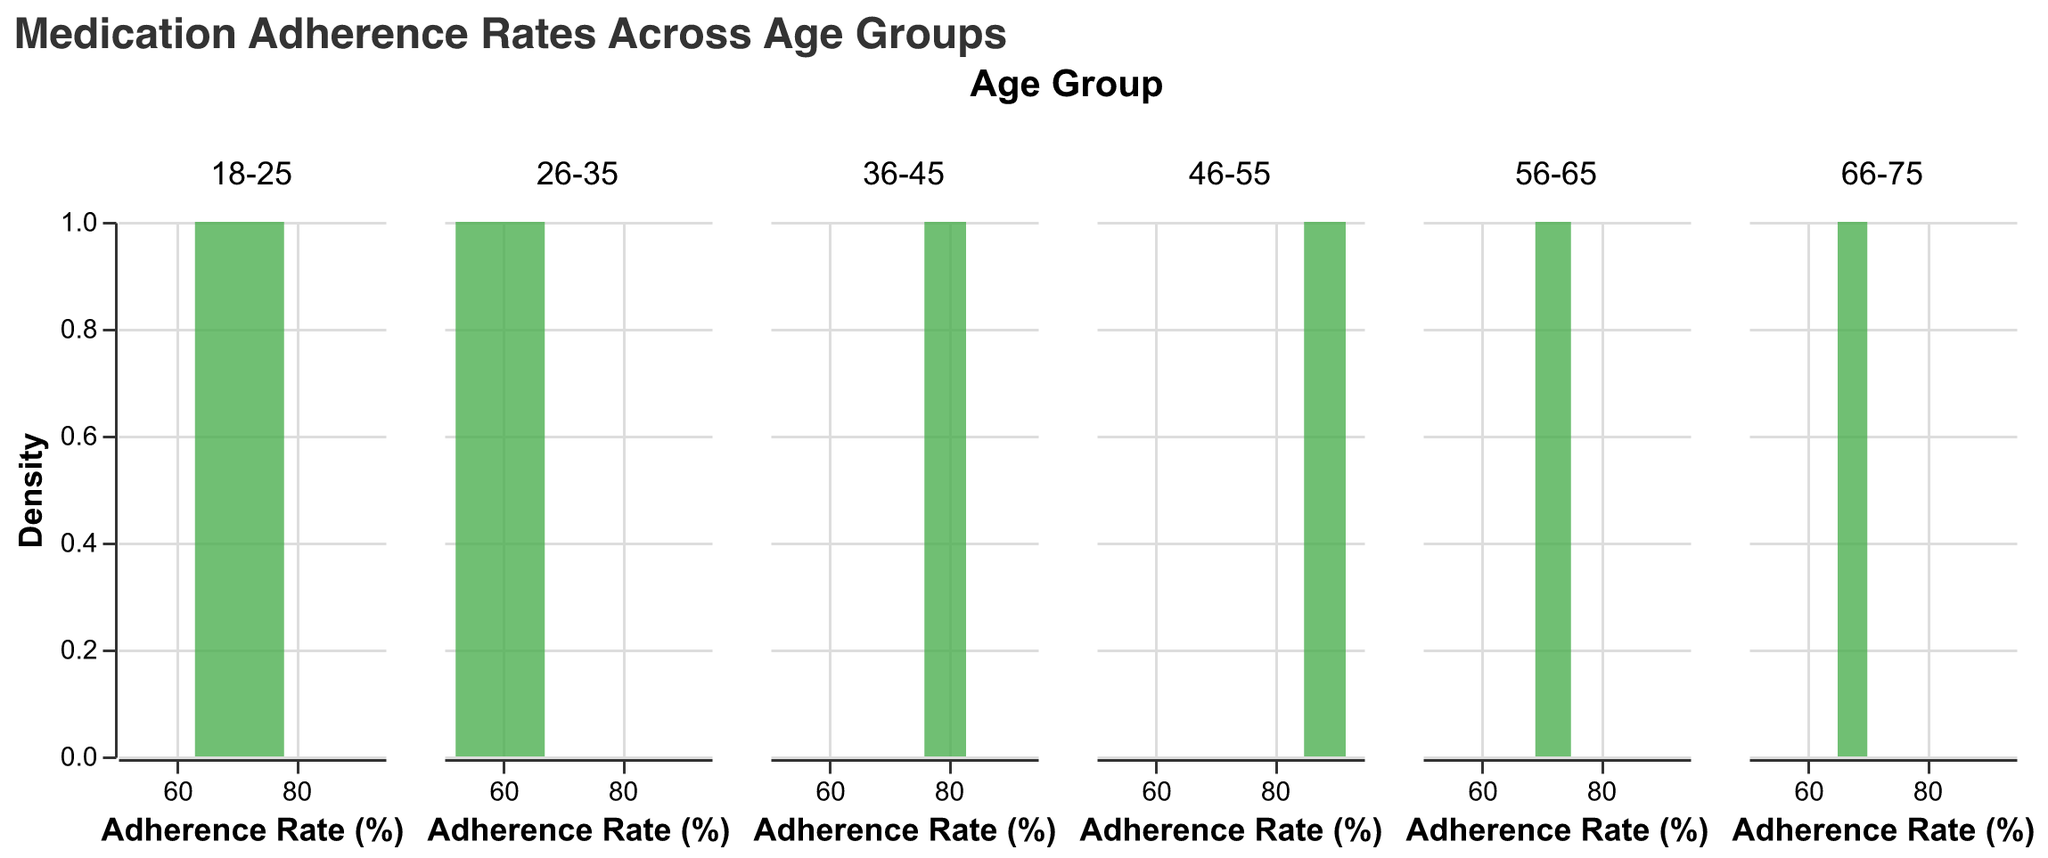what's the title of the figure? The title of the figure is prominently displayed at the top of the plot and provides a summary of what the plot is about. By reading it, we can understand that the plot is about "Medication Adherence Rates Across Age Groups".
Answer: Medication Adherence Rates Across Age Groups what age group has the highest peak in medication adherence rate? By looking at the density plots for each age group, we can compare the peaks. The age group 46-55 shows the highest peak in the density curve indicating a higher concentration of adherence rates.
Answer: 46-55 which age group has the widest spread of medication adherence rates? By comparing the spreads of the density curves for each age group, the age group 36-45 has the widest spread of medication adherence rates, covering a range from approximately 76% to 83%.
Answer: 36-45 what is the most common medication adherence rate for the age group 18-25? The peak of the density plot for the age group 18-25 indicates the most common or frequent value. In this case, the peak is around 70%.
Answer: 70% which age groups have adherence rates that fall below 60%? By inspecting the density plots, the age groups 18-25 and 26-35 show densities that extend below 60%, indicating that some patients in these age groups have adherence rates below this threshold.
Answer: 18-25, 26-35 how does the adherence rate distribution differ between the age groups 46-55 and 66-75? Comparing the density plots for the age groups 46-55 and 66-75, we can see that 46-55 has higher adherence rates clustered around 88-90%, while 66-75 has adherence rates mostly around 65-70%. This indicates a higher adherence rate in the 46-55 group.
Answer: 46-55 has higher adherence rates clustered around 88-90%, while 66-75 has adherence rates mostly around 65-70% what is the range of adherence rates for the age group 56-65? To determine the range, we observe the spread of the density plot for the age group 56-65. It ranges from approximately 69% to 75%.
Answer: 69%-75% does any age group have an adherence rate exactly at 80%? Looking at the density plots, the age group 36-45 has a peak exactly at 80% indicating some patients have this adherence rate.
Answer: 36-45 how many peaks does the age group 26-35 density plot have? Observing the density plot for 26-35, there is one noticeable peak around the adherence rate of 60%.
Answer: 1 